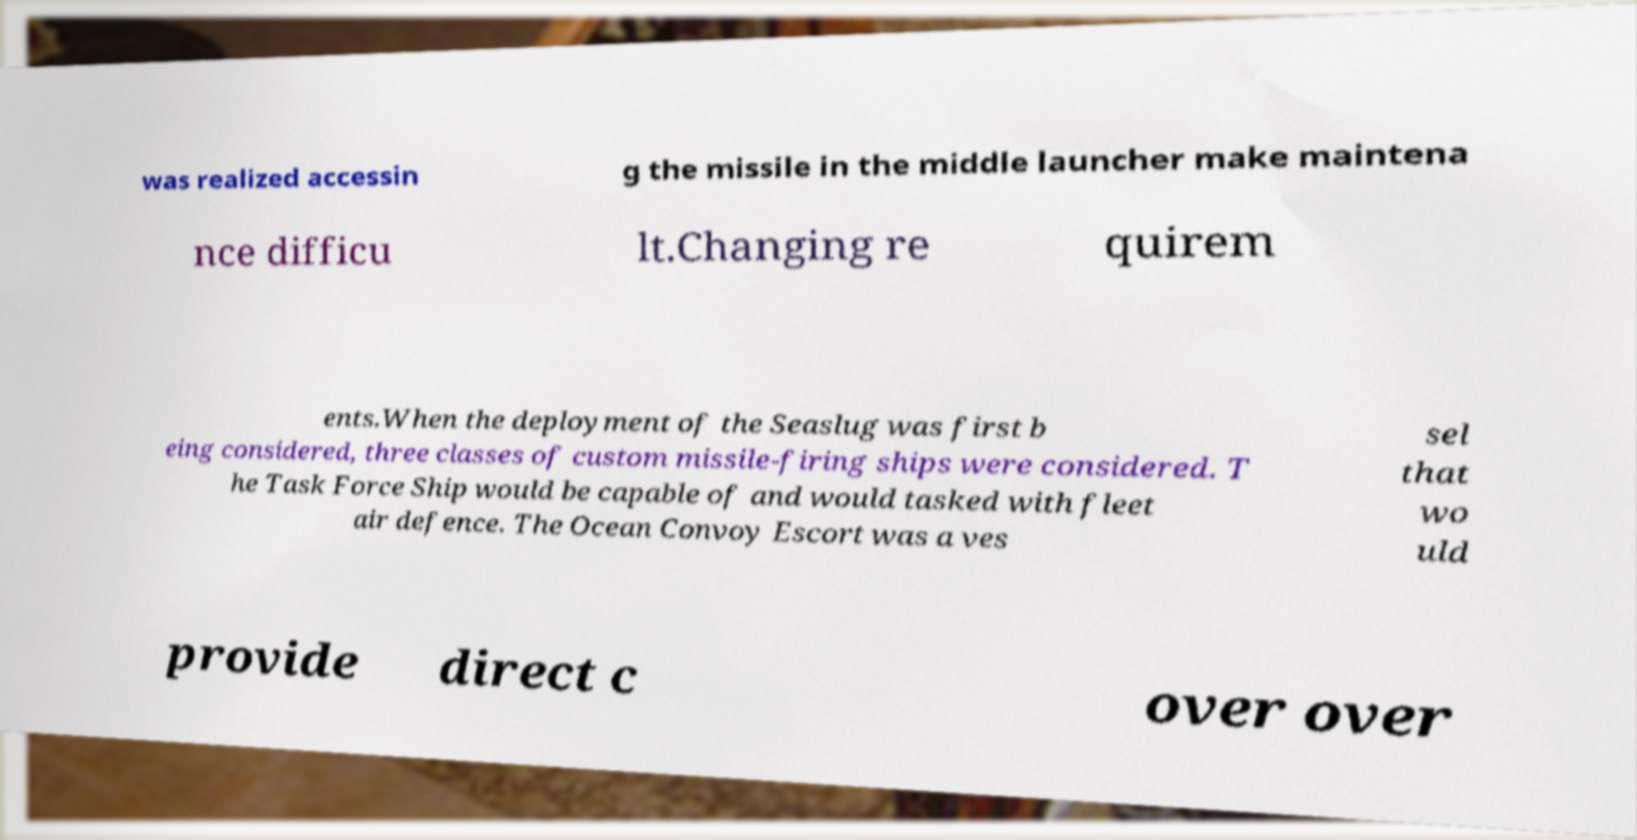I need the written content from this picture converted into text. Can you do that? was realized accessin g the missile in the middle launcher make maintena nce difficu lt.Changing re quirem ents.When the deployment of the Seaslug was first b eing considered, three classes of custom missile-firing ships were considered. T he Task Force Ship would be capable of and would tasked with fleet air defence. The Ocean Convoy Escort was a ves sel that wo uld provide direct c over over 